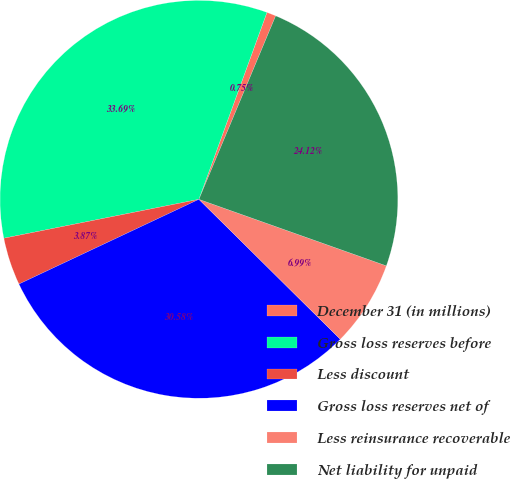<chart> <loc_0><loc_0><loc_500><loc_500><pie_chart><fcel>December 31 (in millions)<fcel>Gross loss reserves before<fcel>Less discount<fcel>Gross loss reserves net of<fcel>Less reinsurance recoverable<fcel>Net liability for unpaid<nl><fcel>0.75%<fcel>33.69%<fcel>3.87%<fcel>30.58%<fcel>6.99%<fcel>24.12%<nl></chart> 